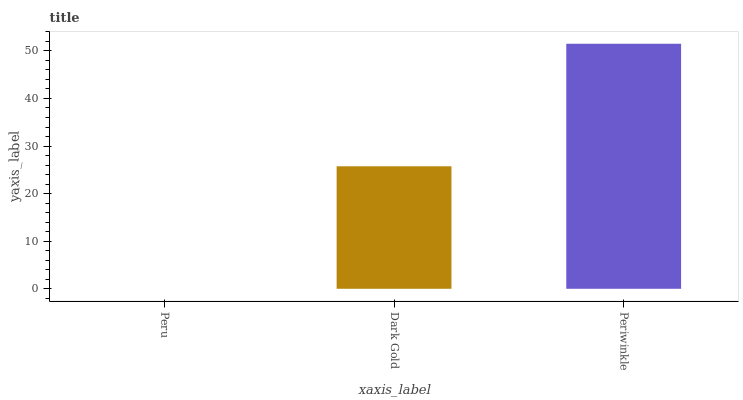Is Peru the minimum?
Answer yes or no. Yes. Is Periwinkle the maximum?
Answer yes or no. Yes. Is Dark Gold the minimum?
Answer yes or no. No. Is Dark Gold the maximum?
Answer yes or no. No. Is Dark Gold greater than Peru?
Answer yes or no. Yes. Is Peru less than Dark Gold?
Answer yes or no. Yes. Is Peru greater than Dark Gold?
Answer yes or no. No. Is Dark Gold less than Peru?
Answer yes or no. No. Is Dark Gold the high median?
Answer yes or no. Yes. Is Dark Gold the low median?
Answer yes or no. Yes. Is Periwinkle the high median?
Answer yes or no. No. Is Peru the low median?
Answer yes or no. No. 